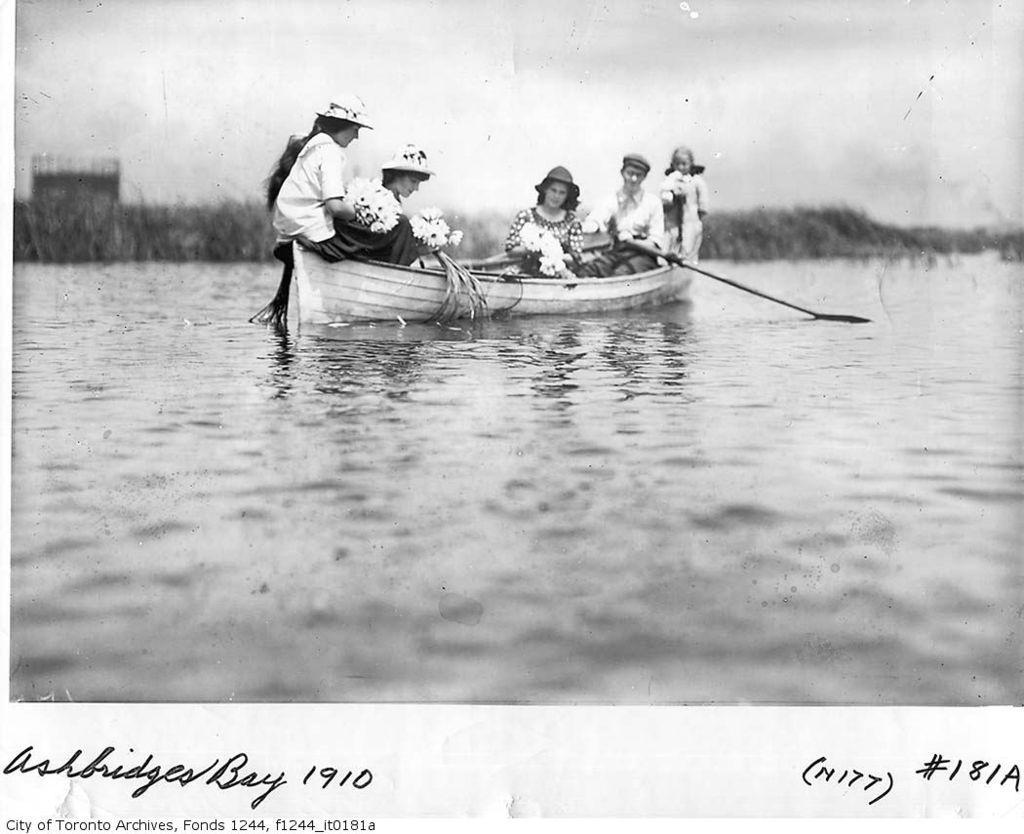In one or two sentences, can you explain what this image depicts? In the foreground I can see a group of people are boating in the water. In the background I can see plants. On the top I can see the sky. This image is taken may be in the lake. 